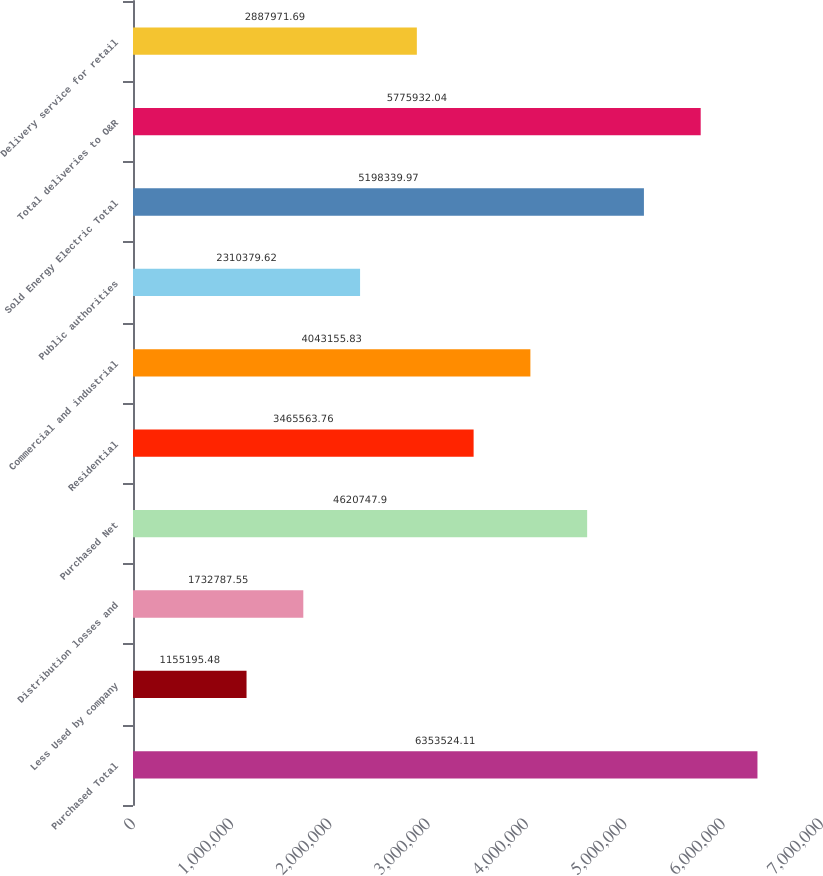<chart> <loc_0><loc_0><loc_500><loc_500><bar_chart><fcel>Purchased Total<fcel>Less Used by company<fcel>Distribution losses and<fcel>Purchased Net<fcel>Residential<fcel>Commercial and industrial<fcel>Public authorities<fcel>Sold Energy Electric Total<fcel>Total deliveries to O&R<fcel>Delivery service for retail<nl><fcel>6.35352e+06<fcel>1.1552e+06<fcel>1.73279e+06<fcel>4.62075e+06<fcel>3.46556e+06<fcel>4.04316e+06<fcel>2.31038e+06<fcel>5.19834e+06<fcel>5.77593e+06<fcel>2.88797e+06<nl></chart> 